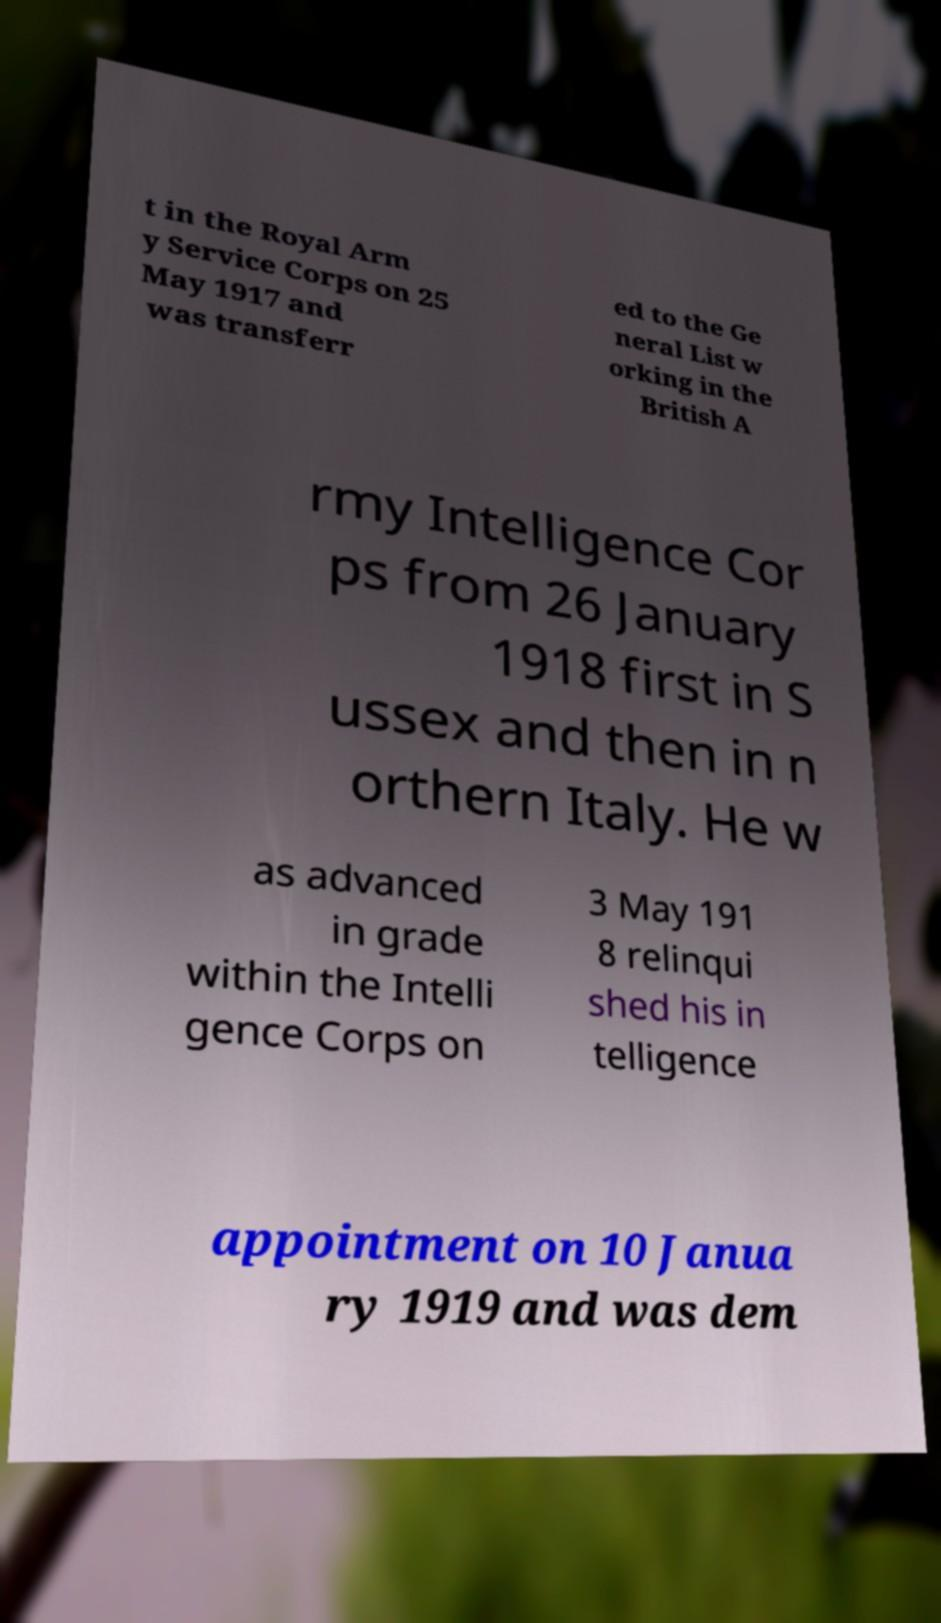There's text embedded in this image that I need extracted. Can you transcribe it verbatim? t in the Royal Arm y Service Corps on 25 May 1917 and was transferr ed to the Ge neral List w orking in the British A rmy Intelligence Cor ps from 26 January 1918 first in S ussex and then in n orthern Italy. He w as advanced in grade within the Intelli gence Corps on 3 May 191 8 relinqui shed his in telligence appointment on 10 Janua ry 1919 and was dem 